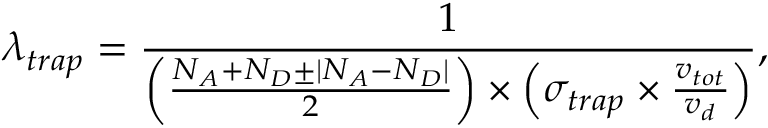Convert formula to latex. <formula><loc_0><loc_0><loc_500><loc_500>{ \lambda _ { t r a p } } = \frac { 1 } { \left ( \frac { { N _ { A } + N _ { D } } \pm | { N _ { A } - N _ { D } } | } { 2 } \right ) \times \left ( \sigma _ { t r a p } \times \frac { v _ { t o t } } { v _ { d } } \right ) } ,</formula> 